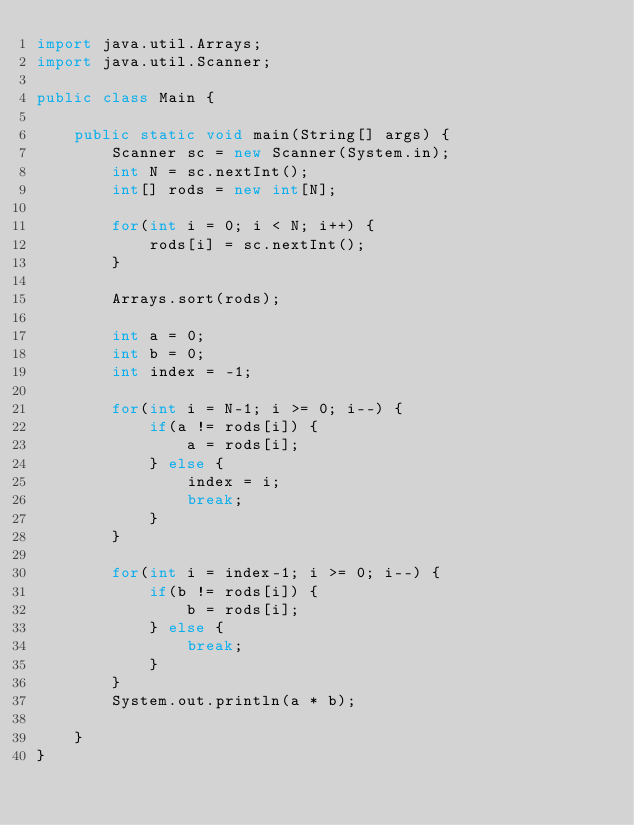<code> <loc_0><loc_0><loc_500><loc_500><_Java_>import java.util.Arrays;
import java.util.Scanner;

public class Main {

	public static void main(String[] args) {
		Scanner sc = new Scanner(System.in);
		int N = sc.nextInt();
		int[] rods = new int[N];

		for(int i = 0; i < N; i++) {
			rods[i] = sc.nextInt();
		}

		Arrays.sort(rods);

		int a = 0;
		int b = 0;
		int index = -1;

		for(int i = N-1; i >= 0; i--) {
			if(a != rods[i]) {
				a = rods[i];
			} else {
				index = i;
				break;
			}
		}

		for(int i = index-1; i >= 0; i--) {
			if(b != rods[i]) {
				b = rods[i];
			} else {
				break;
			}
		}
		System.out.println(a * b);

	}
}</code> 